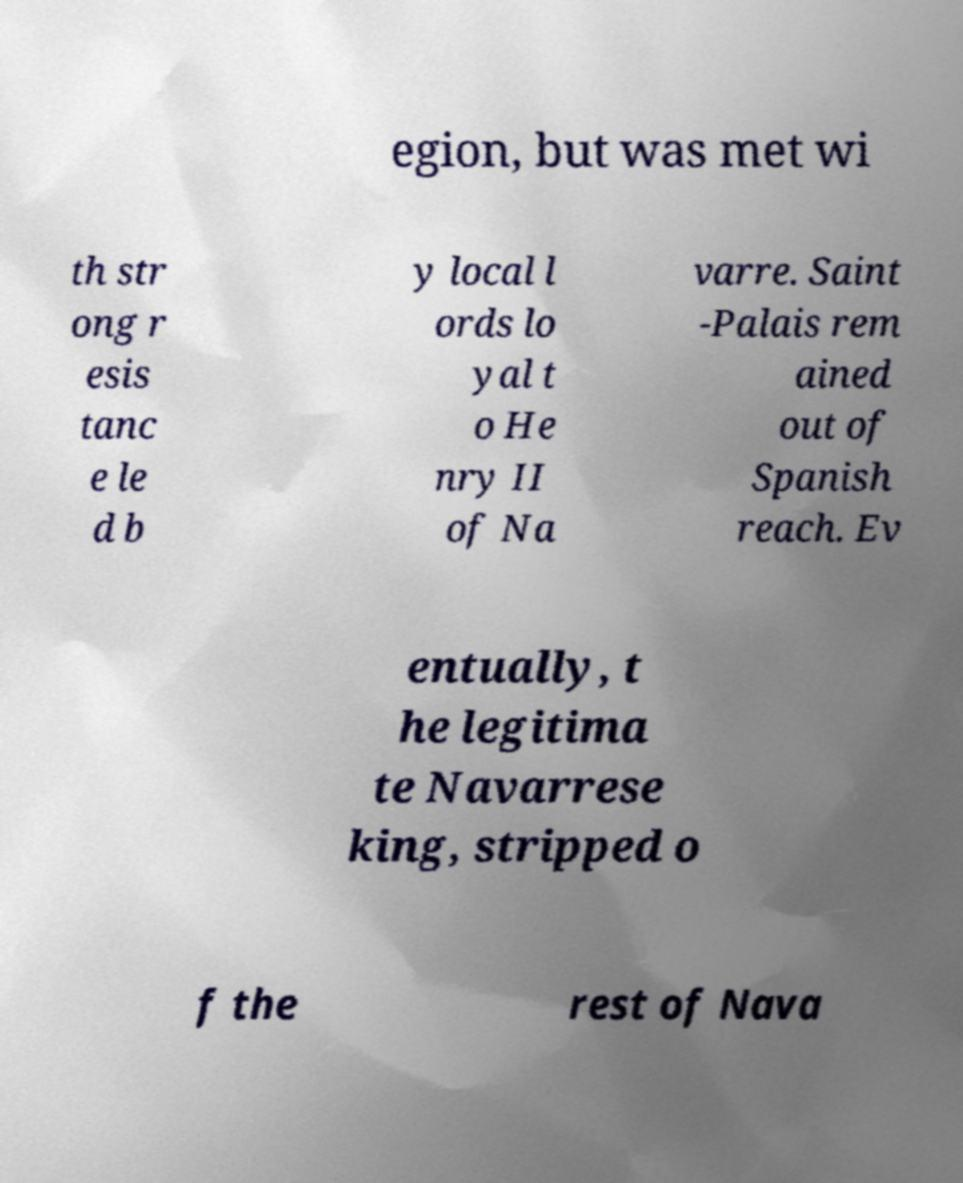Could you assist in decoding the text presented in this image and type it out clearly? egion, but was met wi th str ong r esis tanc e le d b y local l ords lo yal t o He nry II of Na varre. Saint -Palais rem ained out of Spanish reach. Ev entually, t he legitima te Navarrese king, stripped o f the rest of Nava 